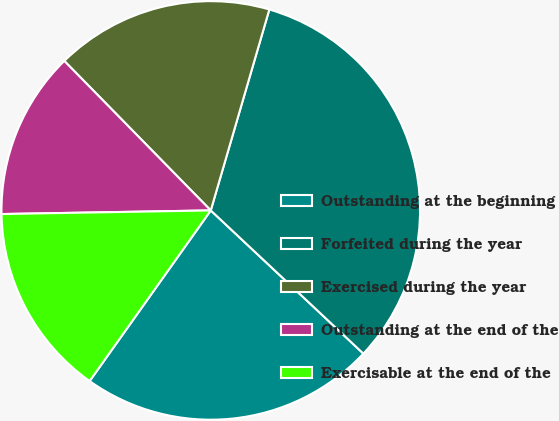Convert chart to OTSL. <chart><loc_0><loc_0><loc_500><loc_500><pie_chart><fcel>Outstanding at the beginning<fcel>Forfeited during the year<fcel>Exercised during the year<fcel>Outstanding at the end of the<fcel>Exercisable at the end of the<nl><fcel>22.83%<fcel>32.48%<fcel>16.85%<fcel>12.94%<fcel>14.9%<nl></chart> 